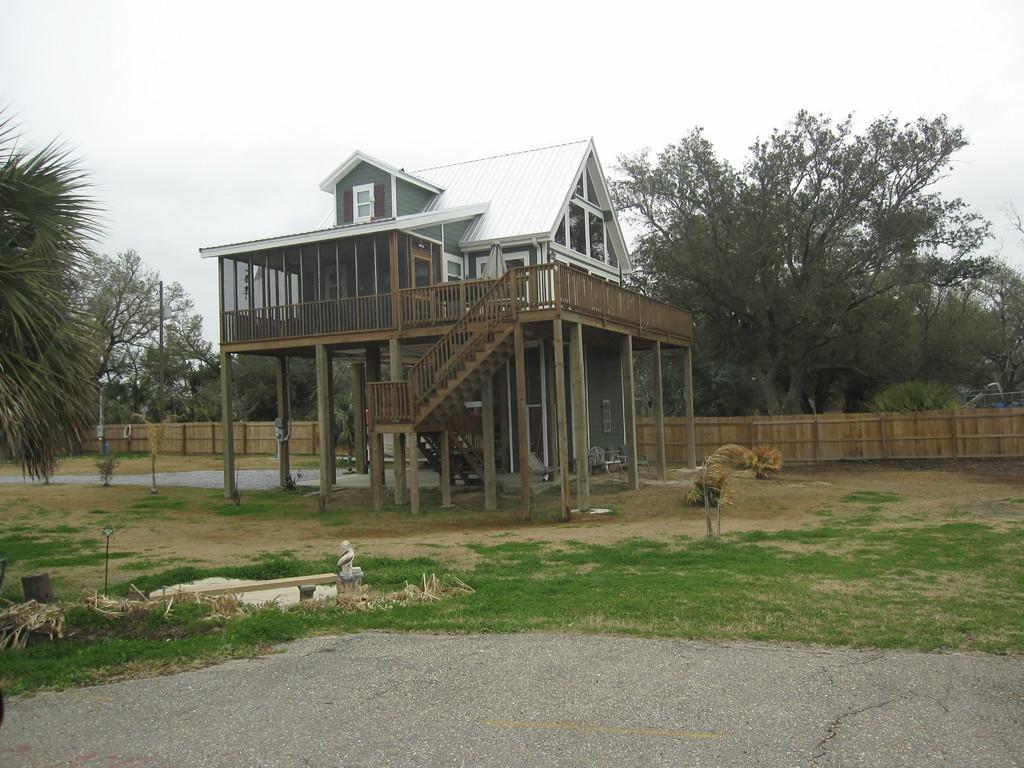Could you give a brief overview of what you see in this image? In the center of the image there is a house. In the background of the image there are trees. At the bottom of the image there is road. There is grass. At the top of the image there is sky. 